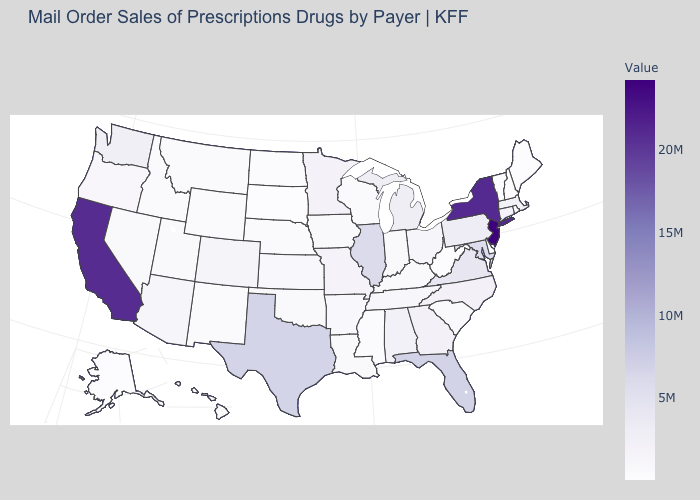Does Georgia have a lower value than California?
Concise answer only. Yes. Which states have the lowest value in the USA?
Keep it brief. Vermont. Does the map have missing data?
Give a very brief answer. No. 